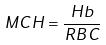Convert formula to latex. <formula><loc_0><loc_0><loc_500><loc_500>M C H = \frac { H b } { R B C }</formula> 